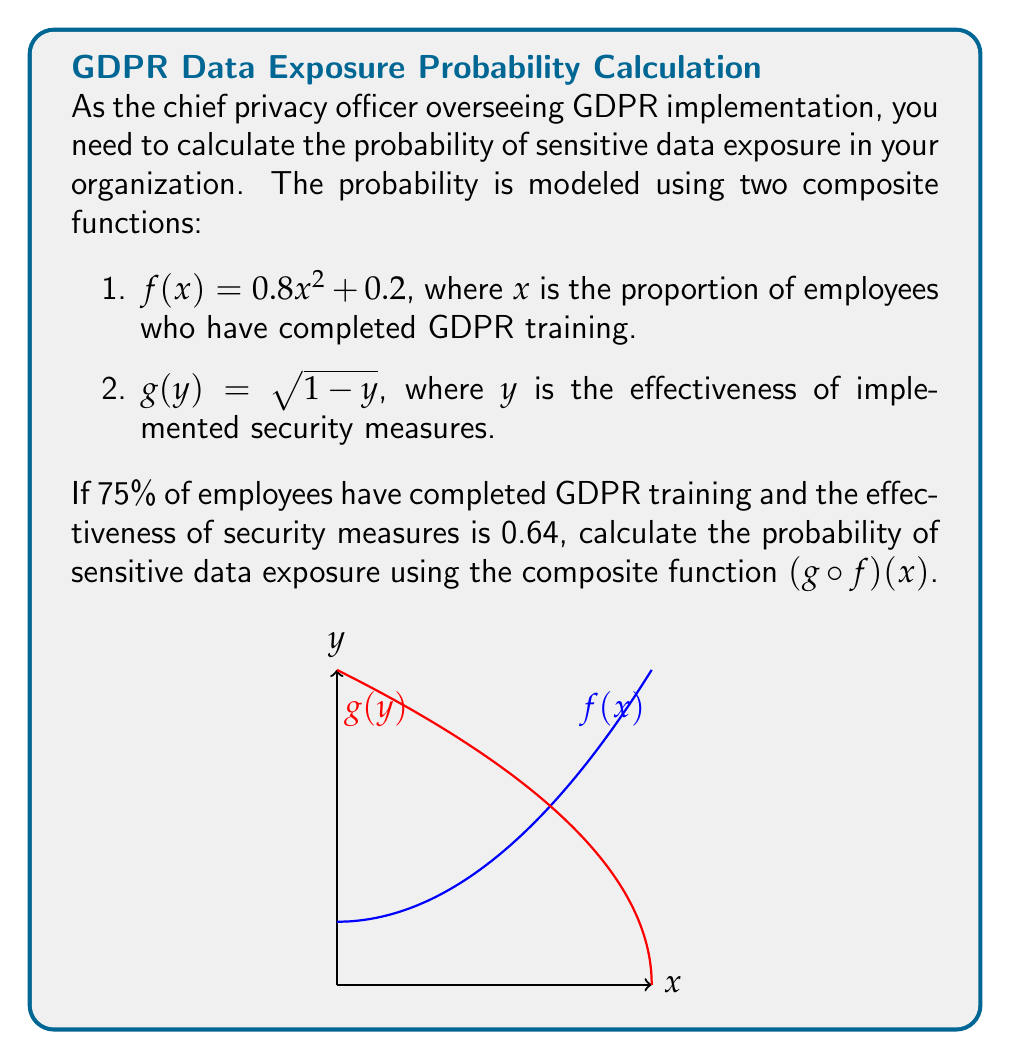What is the answer to this math problem? Let's approach this step-by-step:

1) First, we need to calculate $f(x)$ where $x = 0.75$ (75% of employees have completed training):

   $f(0.75) = 0.8(0.75)^2 + 0.2$
   $= 0.8(0.5625) + 0.2$
   $= 0.45 + 0.2$
   $= 0.65$

2) Now, we need to use this result as the input for $g(y)$. However, we're not using $g(0.65)$ directly. Instead, we're using the composite function $(g \circ f)(x)$, which means we apply $g$ to the result of $f(x)$:

   $(g \circ f)(x) = g(f(x)) = g(0.65)$

3) Let's calculate $g(0.65)$:

   $g(0.65) = \sqrt{1 - 0.65}$
   $= \sqrt{0.35}$
   $\approx 0.5916$

4) Therefore, the probability of sensitive data exposure is approximately 0.5916 or 59.16%.

5) Note that this result makes sense in the context: despite 75% of employees being trained and security measures being 64% effective, there's still a significant probability of data exposure, highlighting the ongoing challenges in data protection.
Answer: $0.5916$ or $59.16\%$ 